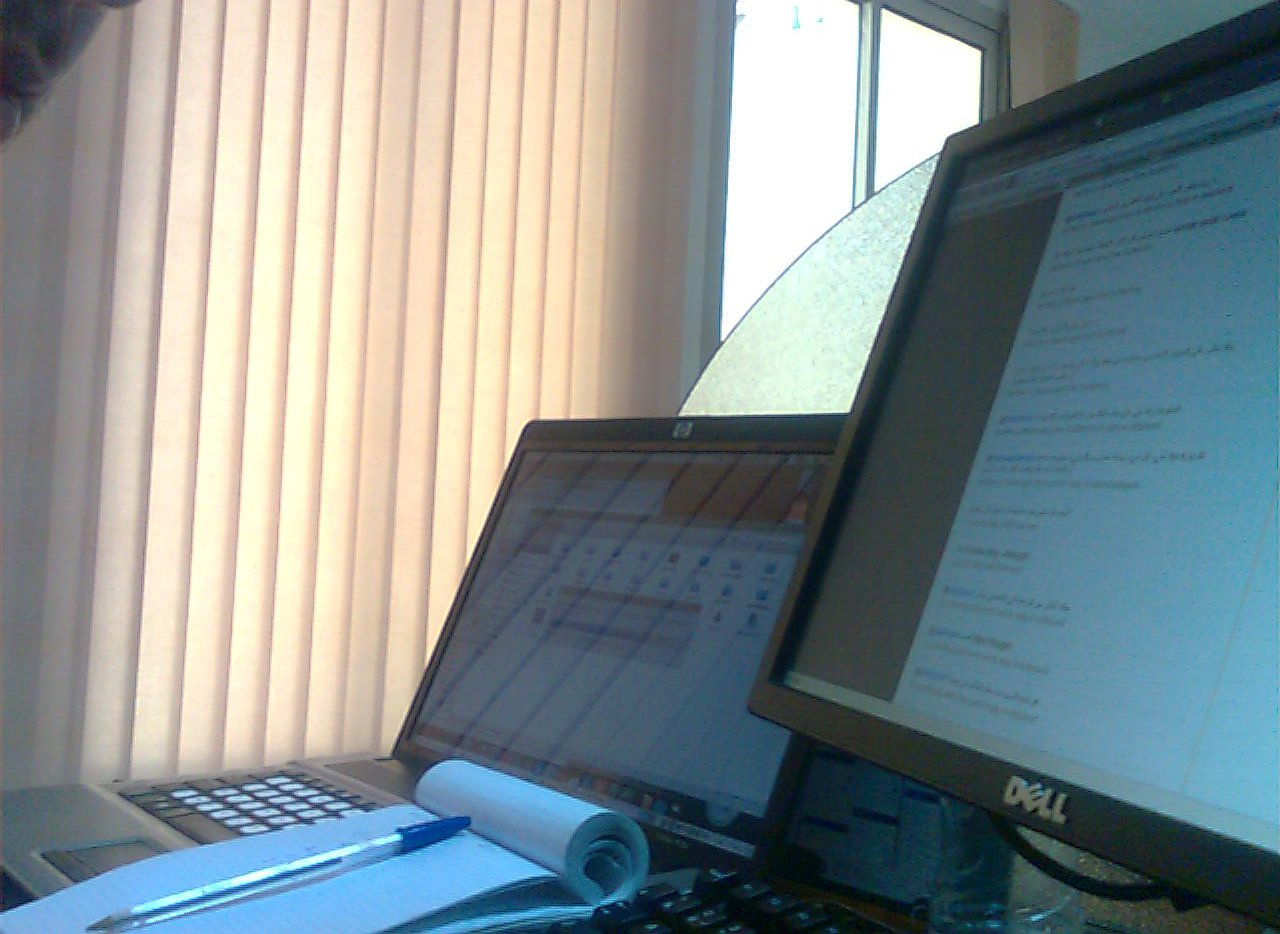Are there any mattresses or chairs? No mattresses or chairs are visible in the image; the scene is entirely occupied by office equipment and supplies. 